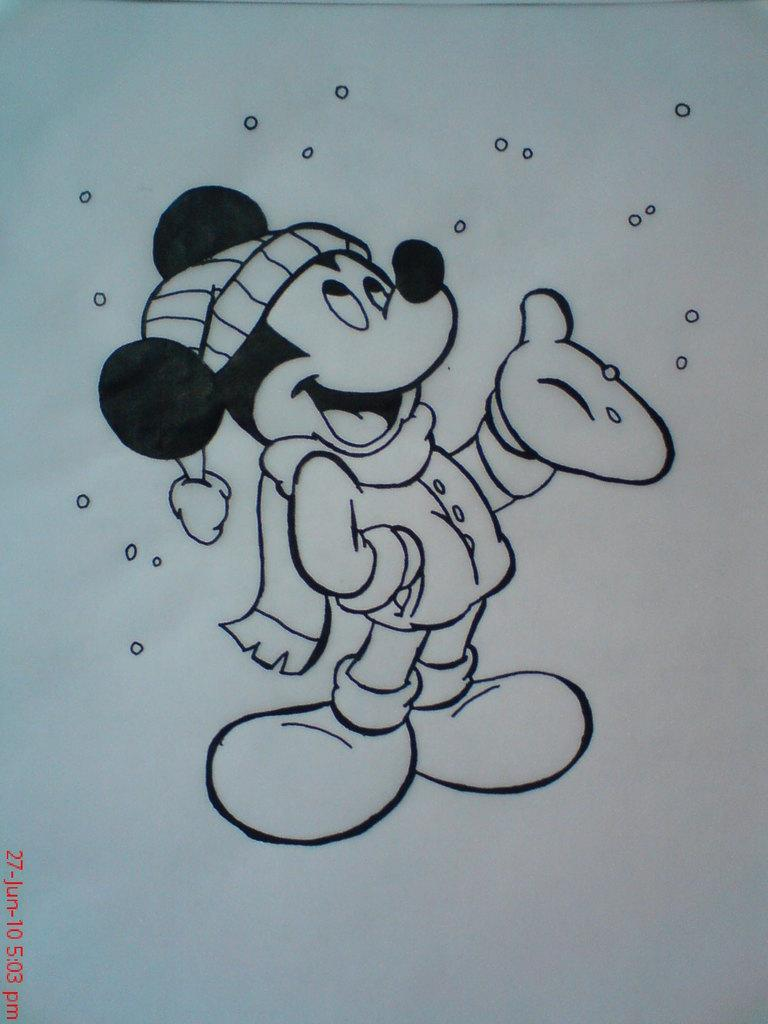What type of drawing is depicted in the image? The image is a sketch. What character can be seen in the sketch? There is a Mickey Mouse in the Mouse in the sketch. What type of writing can be seen on the star in the image? There is no star or writing present in the image; it features a sketch of Mickey Mouse. 